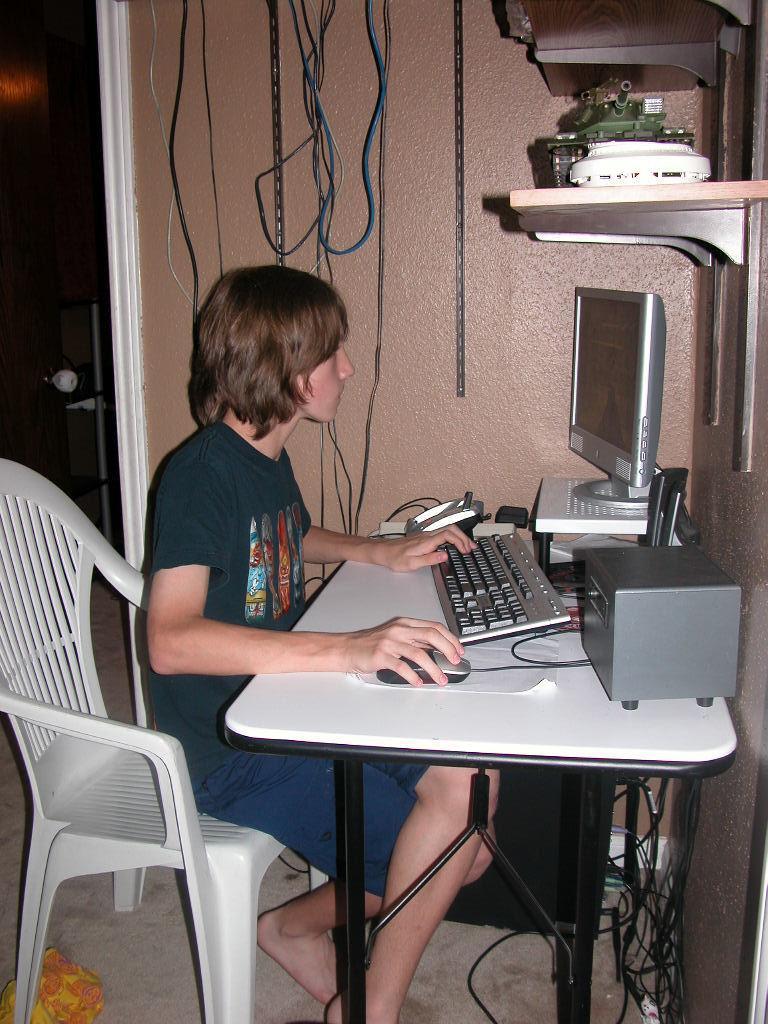Describe this image in one or two sentences. As we can see in the image, there is a person sitting on white color chair. In front of him there is a table. On table there is a paper, mouse, keyboard, system. Beside him there is a wall. 